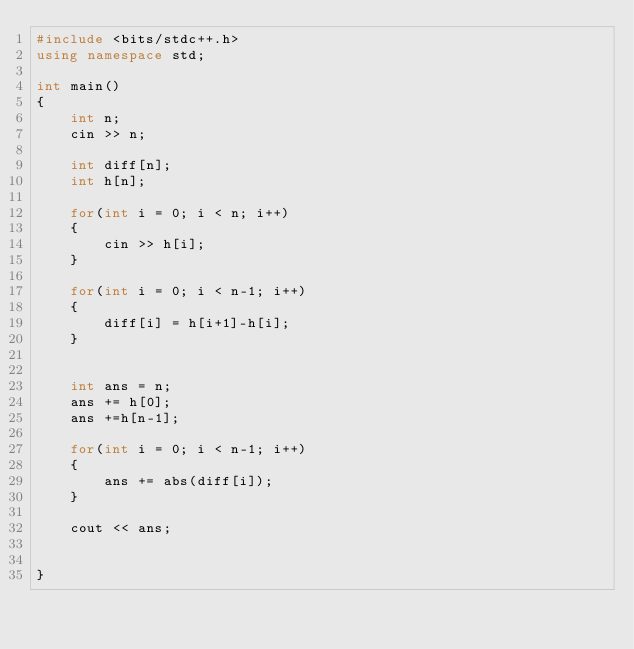Convert code to text. <code><loc_0><loc_0><loc_500><loc_500><_C++_>#include <bits/stdc++.h>
using namespace std;

int main()
{
    int n;
    cin >> n;

    int diff[n];
    int h[n];

    for(int i = 0; i < n; i++)
    {
        cin >> h[i];
    }

    for(int i = 0; i < n-1; i++)
    {
        diff[i] = h[i+1]-h[i];
    }
    

    int ans = n;
    ans += h[0];
    ans +=h[n-1];

    for(int i = 0; i < n-1; i++)
    {
        ans += abs(diff[i]);
    }

    cout << ans;


}</code> 